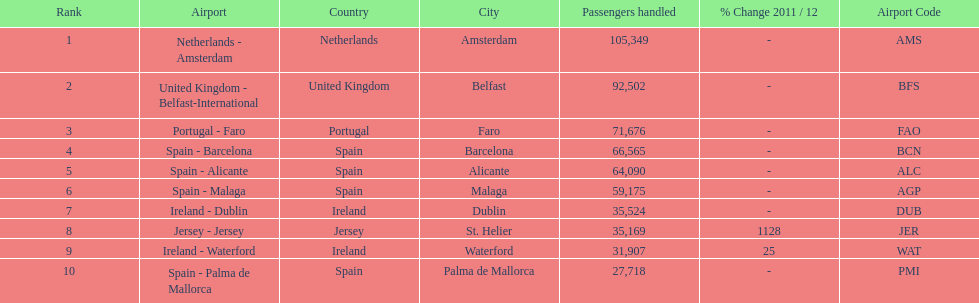Between the topped ranked airport, netherlands - amsterdam, & spain - palma de mallorca, what is the difference in the amount of passengers handled? 77,631. 